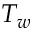<formula> <loc_0><loc_0><loc_500><loc_500>T _ { w }</formula> 